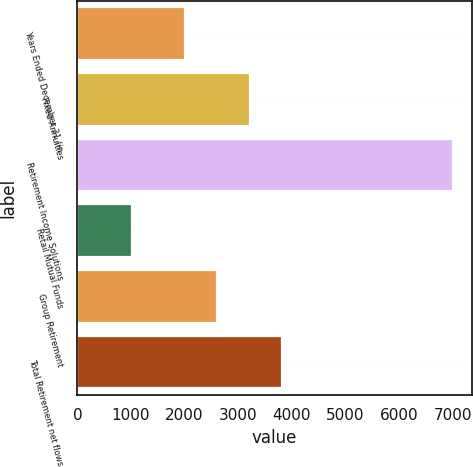Convert chart to OTSL. <chart><loc_0><loc_0><loc_500><loc_500><bar_chart><fcel>Years Ended December 31 (in<fcel>Fixed Annuities<fcel>Retirement Income Solutions<fcel>Retail Mutual Funds<fcel>Group Retirement<fcel>Total Retirement net flows<nl><fcel>2015<fcel>3211.8<fcel>7010<fcel>1026<fcel>2613.4<fcel>3810.2<nl></chart> 